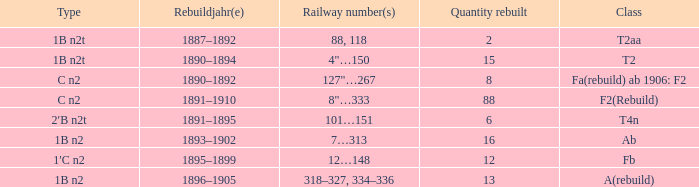What is the total of quantity rebuilt if the type is 1B N2T and the railway number is 88, 118? 1.0. Would you mind parsing the complete table? {'header': ['Type', 'Rebuildjahr(e)', 'Railway number(s)', 'Quantity rebuilt', 'Class'], 'rows': [['1B n2t', '1887–1892', '88, 118', '2', 'T2aa'], ['1B n2t', '1890–1894', '4"…150', '15', 'T2'], ['C n2', '1890–1892', '127"…267', '8', 'Fa(rebuild) ab 1906: F2'], ['C n2', '1891–1910', '8"…333', '88', 'F2(Rebuild)'], ['2′B n2t', '1891–1895', '101…151', '6', 'T4n'], ['1B n2', '1893–1902', '7…313', '16', 'Ab'], ['1′C n2', '1895–1899', '12…148', '12', 'Fb'], ['1B n2', '1896–1905', '318–327, 334–336', '13', 'A(rebuild)']]} 